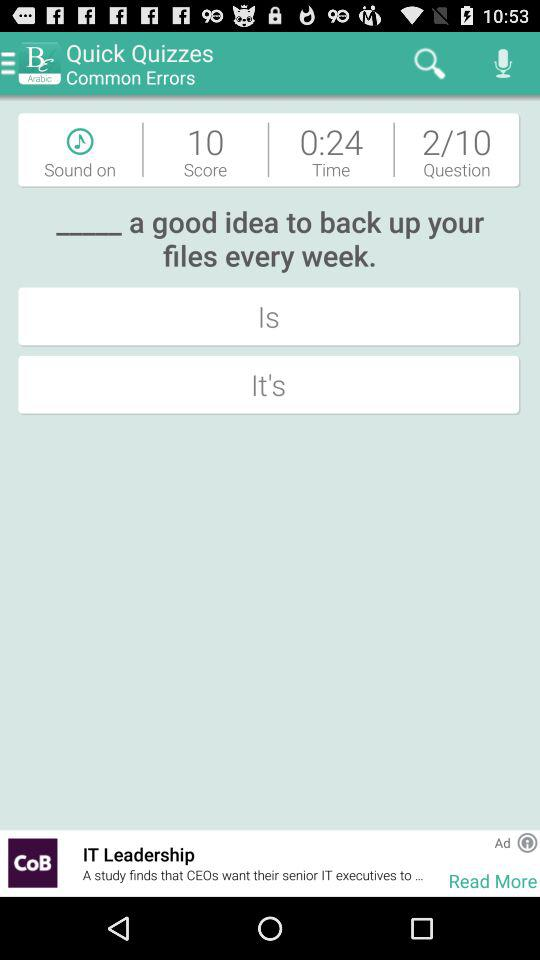What is the status of "Sound"? The status of "Sound" is "on". 